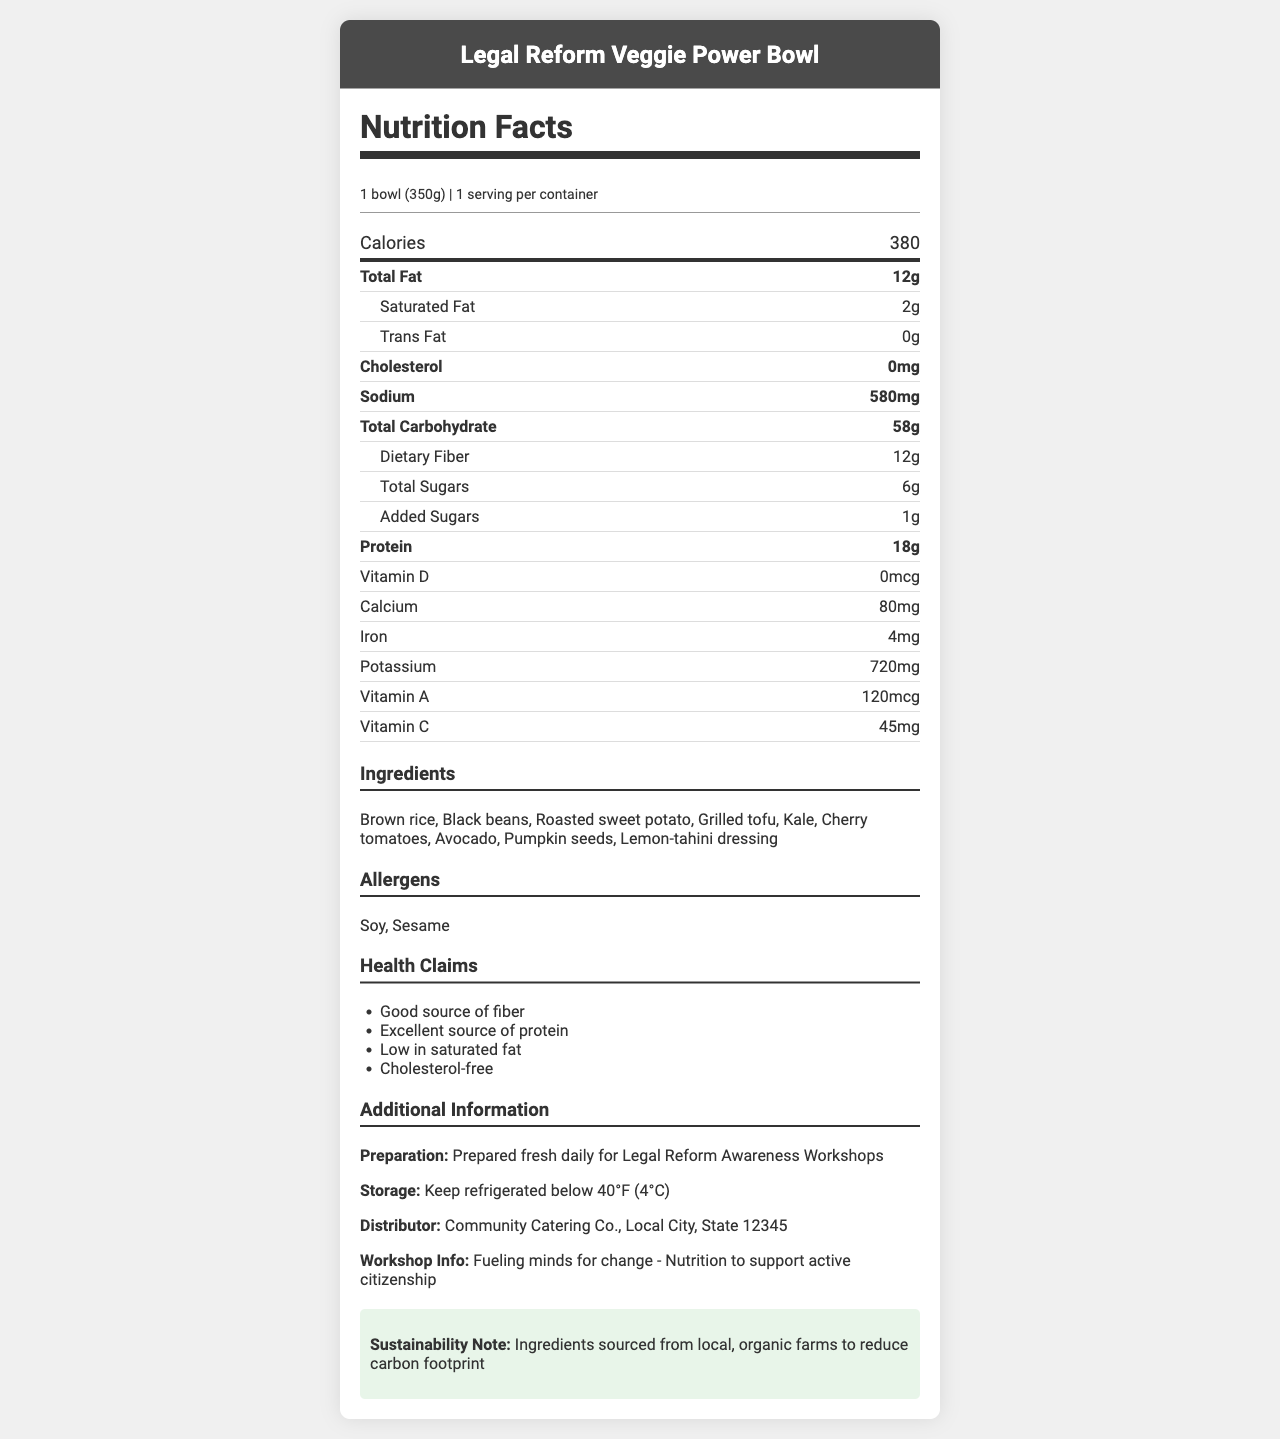what is the serving size of the Legal Reform Veggie Power Bowl? The serving size is clearly stated in the document as "1 bowl (350g)".
Answer: 1 bowl (350g) how many calories are in one Legal Reform Veggie Power Bowl? The document states that there are 380 calories per serving.
Answer: 380 list at least three main ingredients in the Legal Reform Veggie Power Bowl. The ingredients list includes several items; the first three are Brown rice, Black beans, and Roasted sweet potato.
Answer: Brown rice, Black beans, Roasted sweet potato how much protein is in the Legal Reform Veggie Power Bowl? The document specifies that each bowl contains 18g of protein.
Answer: 18g does the Legal Reform Veggie Power Bowl contain any allergens? If yes, what are they? The allergens section lists Soy and Sesame as allergens present in the meal.
Answer: Yes, Soy and Sesame what is the total fat content of the meal? The Total Fat content is listed as 12g in the nutrition facts.
Answer: 12g how much sodium does the Legal Reform Veggie Power Bowl contain? The sodium content is shown as 580mg.
Answer: 580mg what health claims are made about the Legal Reform Veggie Power Bowl? The health claims section lists these four points.
Answer: Good source of fiber, Excellent source of protein, Low in saturated fat, Cholesterol-free where should the Legal Reform Veggie Power Bowl be stored? The storage instructions in the document recommend keeping the bowl refrigerated below 40°F (4°C).
Answer: Keep refrigerated below 40°F (4°C) what is the main benefit highlighted by the "Workshop Specific Info"? The workshop-specific information highlights that the meal provides nutrition to support active citizenship.
Answer: Fueling minds for change - Nutrition to support active citizenship which of the following ingredients is NOT in the Legal Reform Veggie Power Bowl?
A. Avocado
B. Chicken
C. Grilled tofu The ingredients list does not include Chicken, but it includes Avocado and Grilled tofu.
Answer: B which of the following health claims applies to the Legal Reform Veggie Power Bowl?
i. Contains high sodium
ii. Cholesterol-free
iii. High in trans fat The document states that the meal is Cholesterol-free.
Answer: ii is the Legal Reform Veggie Power Bowl suitable for people with soy allergies? The document lists Soy as an allergen, making it unsuitable for people with soy allergies.
Answer: No summarize the main idea conveyed by the document. The document aims to inform participants about the nutritional value and health benefits of the veggie bowl served at the workshops, emphasizing its alignment with sustainability and community health.
Answer: The document provides detailed nutritional information about the Legal Reform Veggie Power Bowl, including ingredients, serving size, calories, and health benefits. It emphasizes that the meal is nutritious, cholesterol-free, and prepared fresh daily using organic and locally-sourced ingredients to support participants in Legal Reform Awareness Workshops. how many bowls are there per container? The document states that there is 1 serving per container, which corresponds to 1 bowl.
Answer: 1 what nutritional information is not provided in the document and would be important for diabetics? The document provides total carbohydrate content but does not differentiate between simple and complex carbohydrates, which is important for diabetics.
Answer: Detailed carbohydrate breakdown such as simple vs. complex carbs 